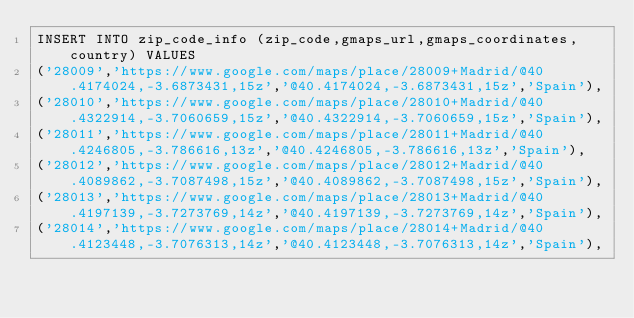<code> <loc_0><loc_0><loc_500><loc_500><_SQL_>INSERT INTO zip_code_info (zip_code,gmaps_url,gmaps_coordinates,country) VALUES
('28009','https://www.google.com/maps/place/28009+Madrid/@40.4174024,-3.6873431,15z','@40.4174024,-3.6873431,15z','Spain'),
('28010','https://www.google.com/maps/place/28010+Madrid/@40.4322914,-3.7060659,15z','@40.4322914,-3.7060659,15z','Spain'),
('28011','https://www.google.com/maps/place/28011+Madrid/@40.4246805,-3.786616,13z','@40.4246805,-3.786616,13z','Spain'),
('28012','https://www.google.com/maps/place/28012+Madrid/@40.4089862,-3.7087498,15z','@40.4089862,-3.7087498,15z','Spain'),
('28013','https://www.google.com/maps/place/28013+Madrid/@40.4197139,-3.7273769,14z','@40.4197139,-3.7273769,14z','Spain'),
('28014','https://www.google.com/maps/place/28014+Madrid/@40.4123448,-3.7076313,14z','@40.4123448,-3.7076313,14z','Spain'),</code> 